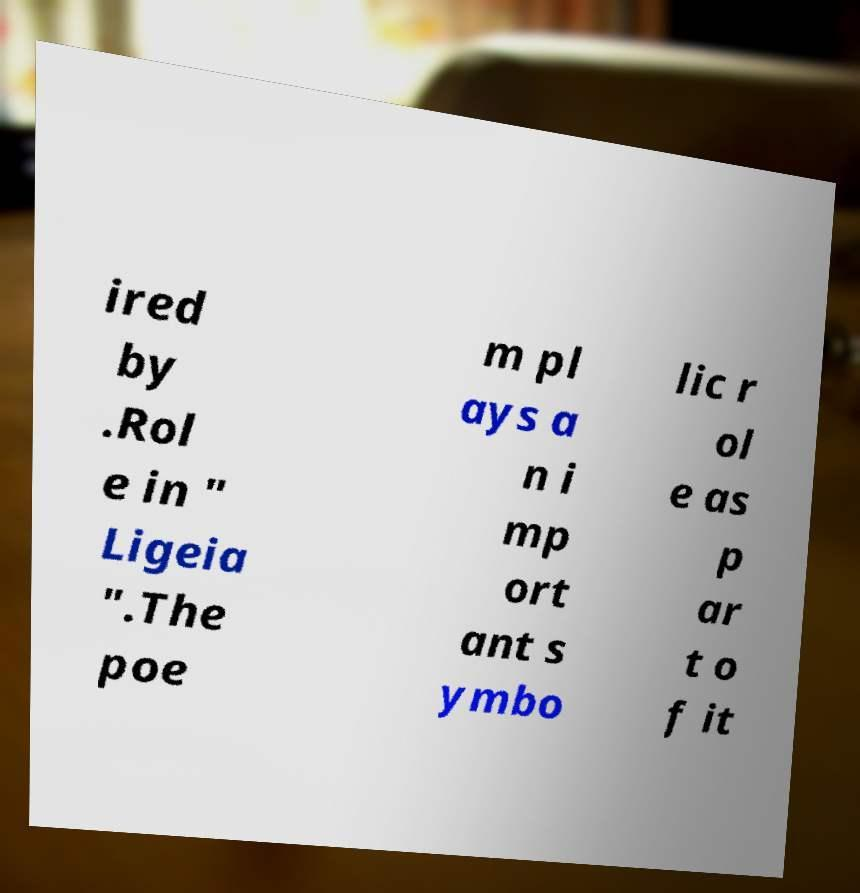There's text embedded in this image that I need extracted. Can you transcribe it verbatim? ired by .Rol e in " Ligeia ".The poe m pl ays a n i mp ort ant s ymbo lic r ol e as p ar t o f it 